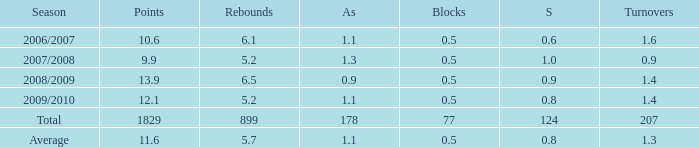How many blocks are there when the rebounds are fewer than 5.2? 0.0. 